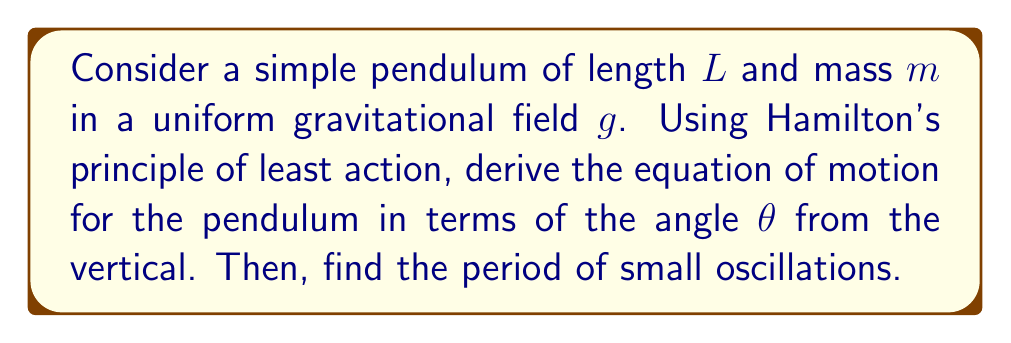Give your solution to this math problem. 1. First, we need to formulate the Lagrangian of the system:
   $$L = T - V$$
   where $T$ is kinetic energy and $V$ is potential energy.

2. The kinetic energy is:
   $$T = \frac{1}{2}m(L\dot{\theta})^2 = \frac{1}{2}mL^2\dot{\theta}^2$$

3. The potential energy is:
   $$V = mgL(1-\cos\theta)$$

4. Thus, the Lagrangian is:
   $$L = \frac{1}{2}mL^2\dot{\theta}^2 - mgL(1-\cos\theta)$$

5. Hamilton's principle states that the action integral should be stationary:
   $$\delta \int_{t_1}^{t_2} L dt = 0$$

6. Applying the Euler-Lagrange equation:
   $$\frac{d}{dt}\left(\frac{\partial L}{\partial \dot{\theta}}\right) - \frac{\partial L}{\partial \theta} = 0$$

7. Calculating the partial derivatives:
   $$\frac{\partial L}{\partial \dot{\theta}} = mL^2\dot{\theta}$$
   $$\frac{\partial L}{\partial \theta} = mgL\sin\theta$$

8. Substituting into the Euler-Lagrange equation:
   $$mL^2\ddot{\theta} + mgL\sin\theta = 0$$

9. Simplifying:
   $$\ddot{\theta} + \frac{g}{L}\sin\theta = 0$$

This is the equation of motion for the pendulum.

10. For small oscillations, $\sin\theta \approx \theta$, so the equation becomes:
    $$\ddot{\theta} + \frac{g}{L}\theta = 0$$

11. This is the equation for simple harmonic motion with angular frequency:
    $$\omega = \sqrt{\frac{g}{L}}$$

12. The period of oscillation is:
    $$T = \frac{2\pi}{\omega} = 2\pi\sqrt{\frac{L}{g}}$$
Answer: $T = 2\pi\sqrt{\frac{L}{g}}$ 